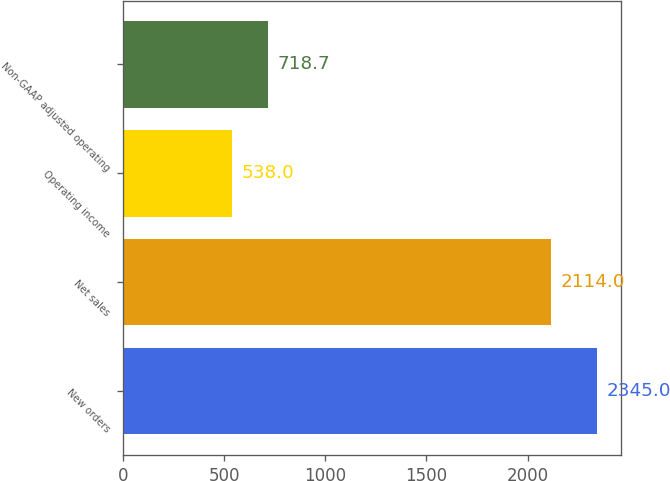Convert chart to OTSL. <chart><loc_0><loc_0><loc_500><loc_500><bar_chart><fcel>New orders<fcel>Net sales<fcel>Operating income<fcel>Non-GAAP adjusted operating<nl><fcel>2345<fcel>2114<fcel>538<fcel>718.7<nl></chart> 